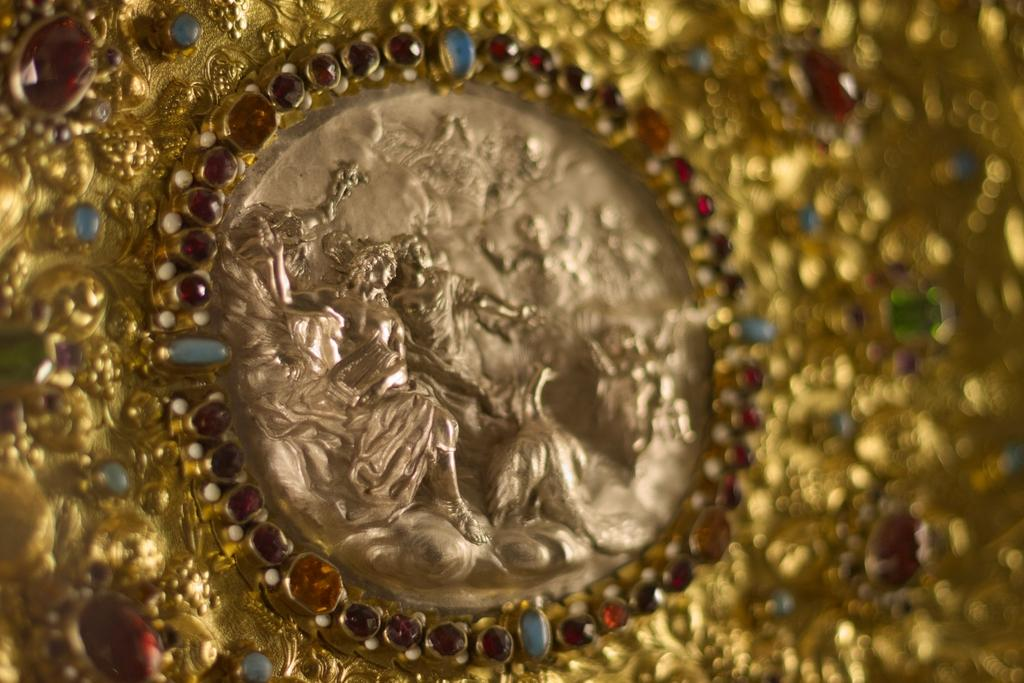What is the color of the object in the image? The object in the image is golden-colored. What can be found in the center of the image? There are sculptures in the center of the image. What book is the dad reading to the children on the trail in the image? There is no book, dad, or trail present in the image. 